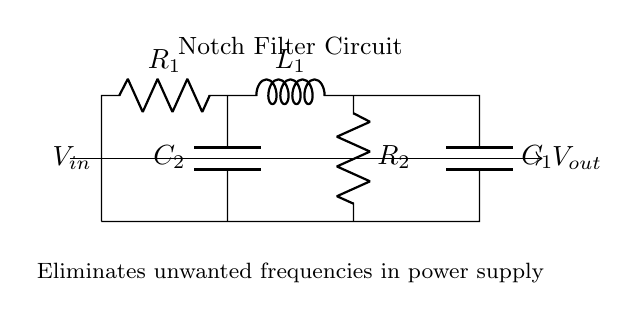What type of filter is depicted in the circuit diagram? The circuit is labeled as a notch filter, which specifically targets and eliminates unwanted frequencies, typically in power supply circuits.
Answer: Notch filter What components are used in this notch filter circuit? The circuit comprises two resistors, two capacitors, and one inductor, indicated as R1, R2, C1, C2, and L1 in the diagram.
Answer: R1, R2, C1, C2, L1 Which components form the tank circuit in this notch filter? In a notch filter, the tank circuit is typically formed by the inductor and capacitor in parallel. Here, L1 and C1 make up the tank circuit.
Answer: L1 and C1 What is the role of the resistors in this circuit? The resistors, R1 and R2, serve to dampen the circuit response and help shape the filter characteristics. They also limit the current and affect the bandwidth of the notch filter.
Answer: Damping and shaping How does the notch filter impact the signal passing through it? The notch filter allows signals at frequencies other than the stopband frequency (the unwanted frequency) to pass while attenuating the signals at that specific frequency. This results in a cleaner output free from interference at the targeted frequency.
Answer: Attenuates unwanted frequency At what frequency does the notch filter operate best? The notch filter is typically designed to eliminate a specific frequency, which is determined by the component values (R1, R2, L1, C1, and C2). The exact frequency would require calculating based on these values. Typically, this frequency is referred to as the notch frequency.
Answer: Notch frequency (specific value depends on component values) What is the output voltage in relation to the input voltage? The output voltage is influenced by the filter's design to suppress certain frequencies, leading to a modified voltage that lacks the components of the unwanted frequencies present in the input voltage. The actual output voltage would depend on the specific frequency and the design parameters.
Answer: Depends on frequency 